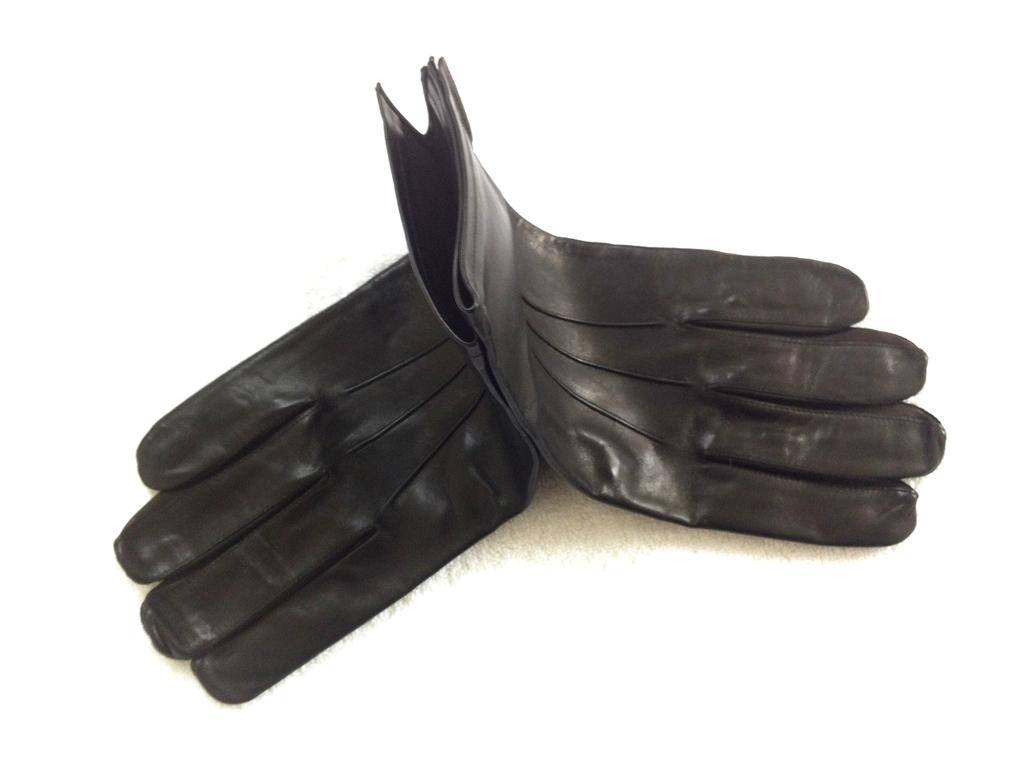What type of clothing item can be seen in the image? There are gloves present in the image. How does the comparison between the gloves and the place they are located affect the overall aesthetic of the image? There is no information provided about the place where the gloves are located or any comparison being made, so it is not possible to answer this question. 